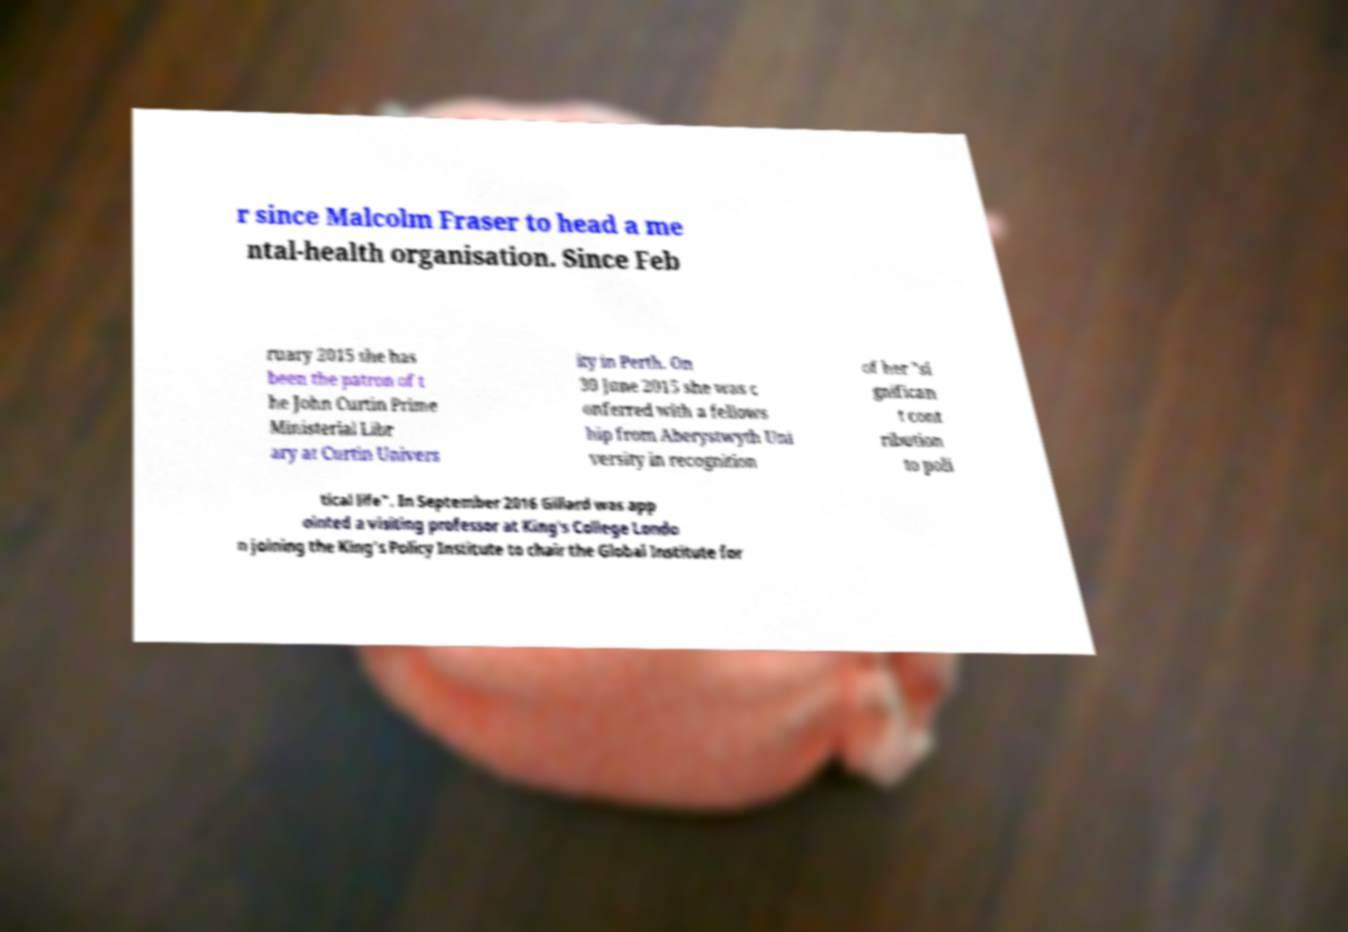Could you assist in decoding the text presented in this image and type it out clearly? r since Malcolm Fraser to head a me ntal-health organisation. Since Feb ruary 2015 she has been the patron of t he John Curtin Prime Ministerial Libr ary at Curtin Univers ity in Perth. On 30 June 2015 she was c onferred with a fellows hip from Aberystwyth Uni versity in recognition of her "si gnifican t cont ribution to poli tical life". In September 2016 Gillard was app ointed a visiting professor at King's College Londo n joining the King's Policy Institute to chair the Global Institute for 